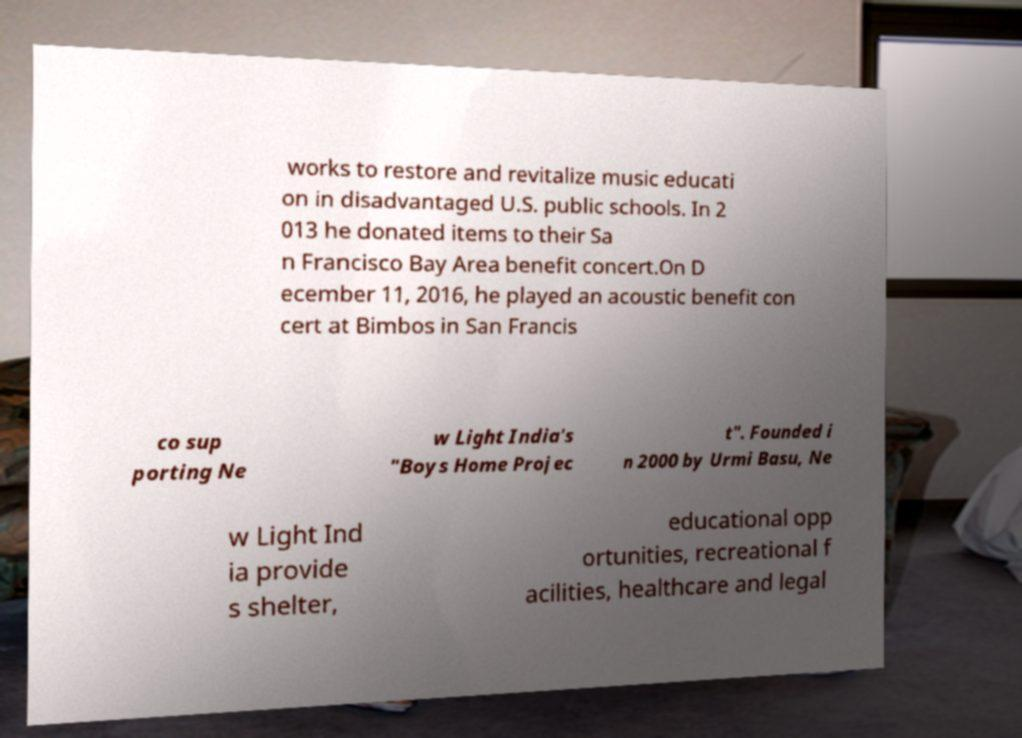There's text embedded in this image that I need extracted. Can you transcribe it verbatim? works to restore and revitalize music educati on in disadvantaged U.S. public schools. In 2 013 he donated items to their Sa n Francisco Bay Area benefit concert.On D ecember 11, 2016, he played an acoustic benefit con cert at Bimbos in San Francis co sup porting Ne w Light India's "Boys Home Projec t". Founded i n 2000 by Urmi Basu, Ne w Light Ind ia provide s shelter, educational opp ortunities, recreational f acilities, healthcare and legal 